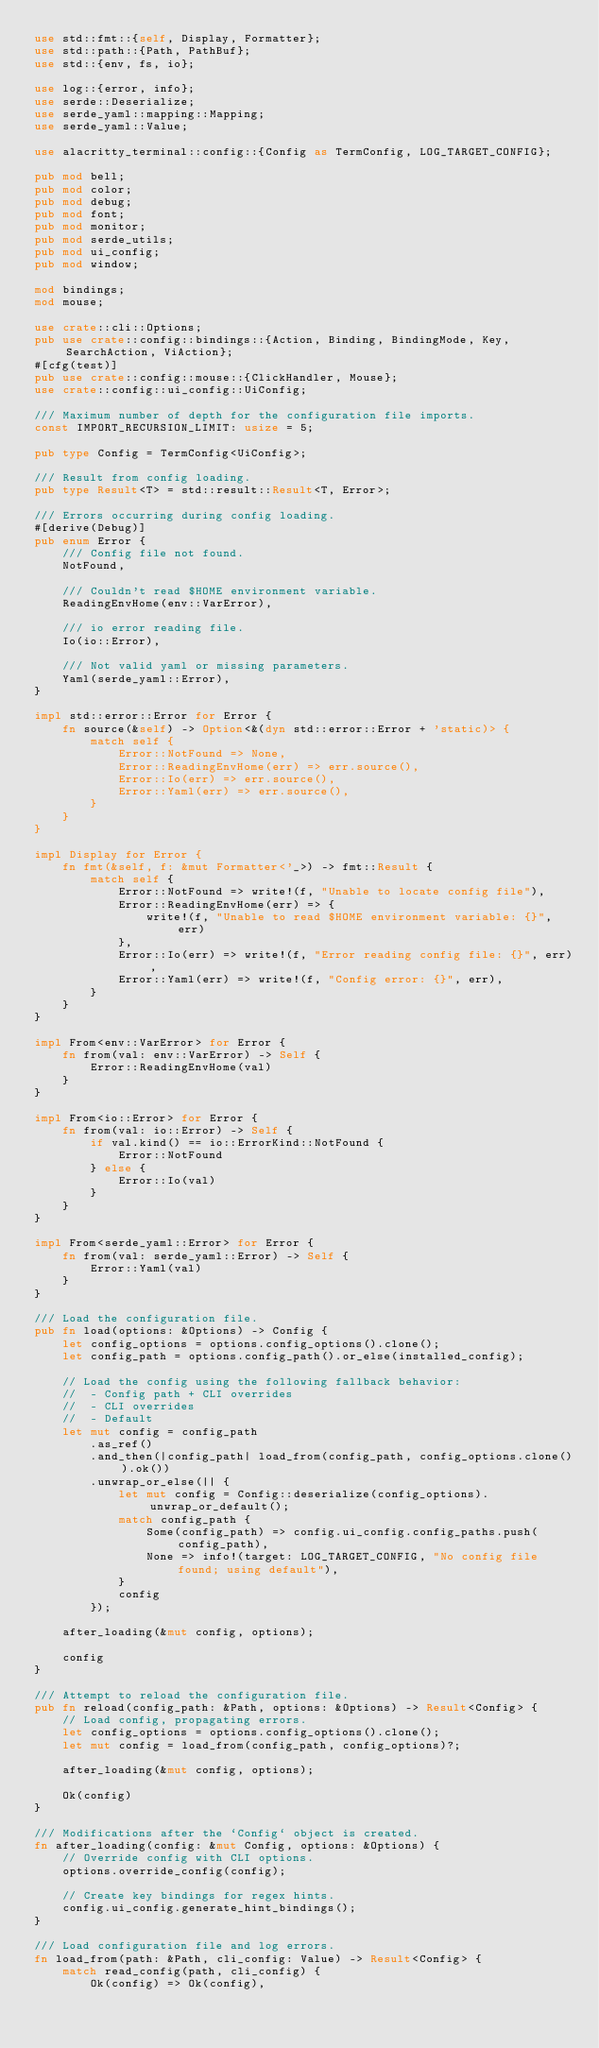Convert code to text. <code><loc_0><loc_0><loc_500><loc_500><_Rust_>use std::fmt::{self, Display, Formatter};
use std::path::{Path, PathBuf};
use std::{env, fs, io};

use log::{error, info};
use serde::Deserialize;
use serde_yaml::mapping::Mapping;
use serde_yaml::Value;

use alacritty_terminal::config::{Config as TermConfig, LOG_TARGET_CONFIG};

pub mod bell;
pub mod color;
pub mod debug;
pub mod font;
pub mod monitor;
pub mod serde_utils;
pub mod ui_config;
pub mod window;

mod bindings;
mod mouse;

use crate::cli::Options;
pub use crate::config::bindings::{Action, Binding, BindingMode, Key, SearchAction, ViAction};
#[cfg(test)]
pub use crate::config::mouse::{ClickHandler, Mouse};
use crate::config::ui_config::UiConfig;

/// Maximum number of depth for the configuration file imports.
const IMPORT_RECURSION_LIMIT: usize = 5;

pub type Config = TermConfig<UiConfig>;

/// Result from config loading.
pub type Result<T> = std::result::Result<T, Error>;

/// Errors occurring during config loading.
#[derive(Debug)]
pub enum Error {
    /// Config file not found.
    NotFound,

    /// Couldn't read $HOME environment variable.
    ReadingEnvHome(env::VarError),

    /// io error reading file.
    Io(io::Error),

    /// Not valid yaml or missing parameters.
    Yaml(serde_yaml::Error),
}

impl std::error::Error for Error {
    fn source(&self) -> Option<&(dyn std::error::Error + 'static)> {
        match self {
            Error::NotFound => None,
            Error::ReadingEnvHome(err) => err.source(),
            Error::Io(err) => err.source(),
            Error::Yaml(err) => err.source(),
        }
    }
}

impl Display for Error {
    fn fmt(&self, f: &mut Formatter<'_>) -> fmt::Result {
        match self {
            Error::NotFound => write!(f, "Unable to locate config file"),
            Error::ReadingEnvHome(err) => {
                write!(f, "Unable to read $HOME environment variable: {}", err)
            },
            Error::Io(err) => write!(f, "Error reading config file: {}", err),
            Error::Yaml(err) => write!(f, "Config error: {}", err),
        }
    }
}

impl From<env::VarError> for Error {
    fn from(val: env::VarError) -> Self {
        Error::ReadingEnvHome(val)
    }
}

impl From<io::Error> for Error {
    fn from(val: io::Error) -> Self {
        if val.kind() == io::ErrorKind::NotFound {
            Error::NotFound
        } else {
            Error::Io(val)
        }
    }
}

impl From<serde_yaml::Error> for Error {
    fn from(val: serde_yaml::Error) -> Self {
        Error::Yaml(val)
    }
}

/// Load the configuration file.
pub fn load(options: &Options) -> Config {
    let config_options = options.config_options().clone();
    let config_path = options.config_path().or_else(installed_config);

    // Load the config using the following fallback behavior:
    //  - Config path + CLI overrides
    //  - CLI overrides
    //  - Default
    let mut config = config_path
        .as_ref()
        .and_then(|config_path| load_from(config_path, config_options.clone()).ok())
        .unwrap_or_else(|| {
            let mut config = Config::deserialize(config_options).unwrap_or_default();
            match config_path {
                Some(config_path) => config.ui_config.config_paths.push(config_path),
                None => info!(target: LOG_TARGET_CONFIG, "No config file found; using default"),
            }
            config
        });

    after_loading(&mut config, options);

    config
}

/// Attempt to reload the configuration file.
pub fn reload(config_path: &Path, options: &Options) -> Result<Config> {
    // Load config, propagating errors.
    let config_options = options.config_options().clone();
    let mut config = load_from(config_path, config_options)?;

    after_loading(&mut config, options);

    Ok(config)
}

/// Modifications after the `Config` object is created.
fn after_loading(config: &mut Config, options: &Options) {
    // Override config with CLI options.
    options.override_config(config);

    // Create key bindings for regex hints.
    config.ui_config.generate_hint_bindings();
}

/// Load configuration file and log errors.
fn load_from(path: &Path, cli_config: Value) -> Result<Config> {
    match read_config(path, cli_config) {
        Ok(config) => Ok(config),</code> 